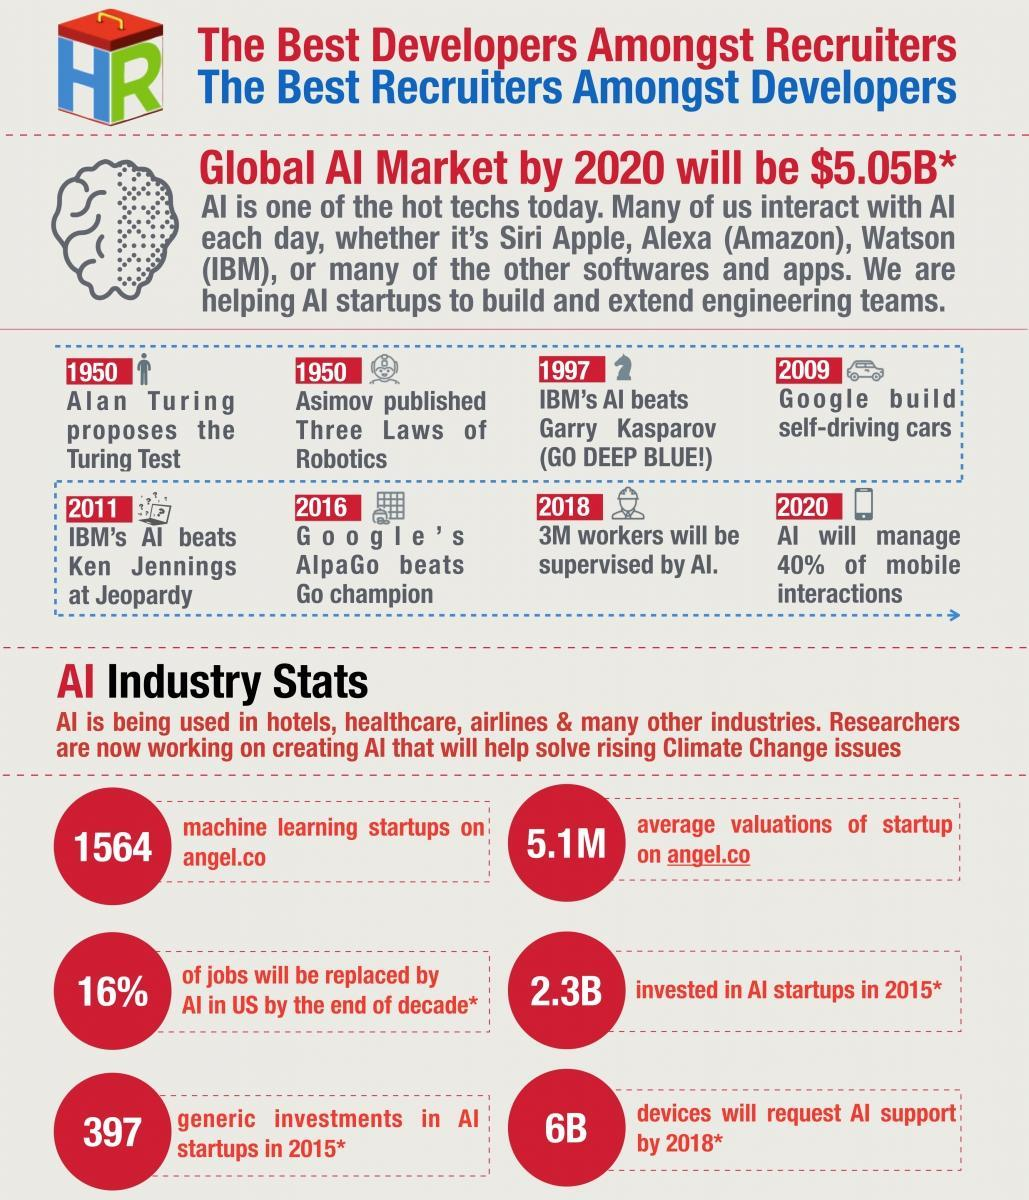When was Ken Jennings beaten by AI
Answer the question with a short phrase. 2011 when was three laws of robotics published 1950 what do we use to interact with AI daily Siri Apple, Alexa (Amazon), Watson (IBM) by when will 3M workers be supervised by AI 2018 What did Asimov publish three laws of robotics 